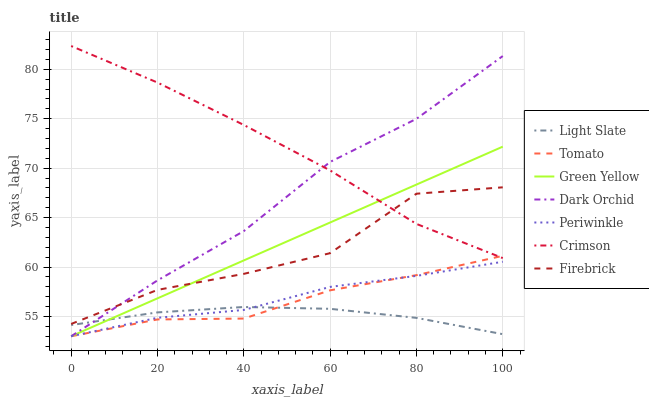Does Light Slate have the minimum area under the curve?
Answer yes or no. Yes. Does Crimson have the maximum area under the curve?
Answer yes or no. Yes. Does Firebrick have the minimum area under the curve?
Answer yes or no. No. Does Firebrick have the maximum area under the curve?
Answer yes or no. No. Is Green Yellow the smoothest?
Answer yes or no. Yes. Is Firebrick the roughest?
Answer yes or no. Yes. Is Light Slate the smoothest?
Answer yes or no. No. Is Light Slate the roughest?
Answer yes or no. No. Does Tomato have the lowest value?
Answer yes or no. Yes. Does Light Slate have the lowest value?
Answer yes or no. No. Does Crimson have the highest value?
Answer yes or no. Yes. Does Firebrick have the highest value?
Answer yes or no. No. Is Periwinkle less than Firebrick?
Answer yes or no. Yes. Is Firebrick greater than Light Slate?
Answer yes or no. Yes. Does Periwinkle intersect Dark Orchid?
Answer yes or no. Yes. Is Periwinkle less than Dark Orchid?
Answer yes or no. No. Is Periwinkle greater than Dark Orchid?
Answer yes or no. No. Does Periwinkle intersect Firebrick?
Answer yes or no. No. 